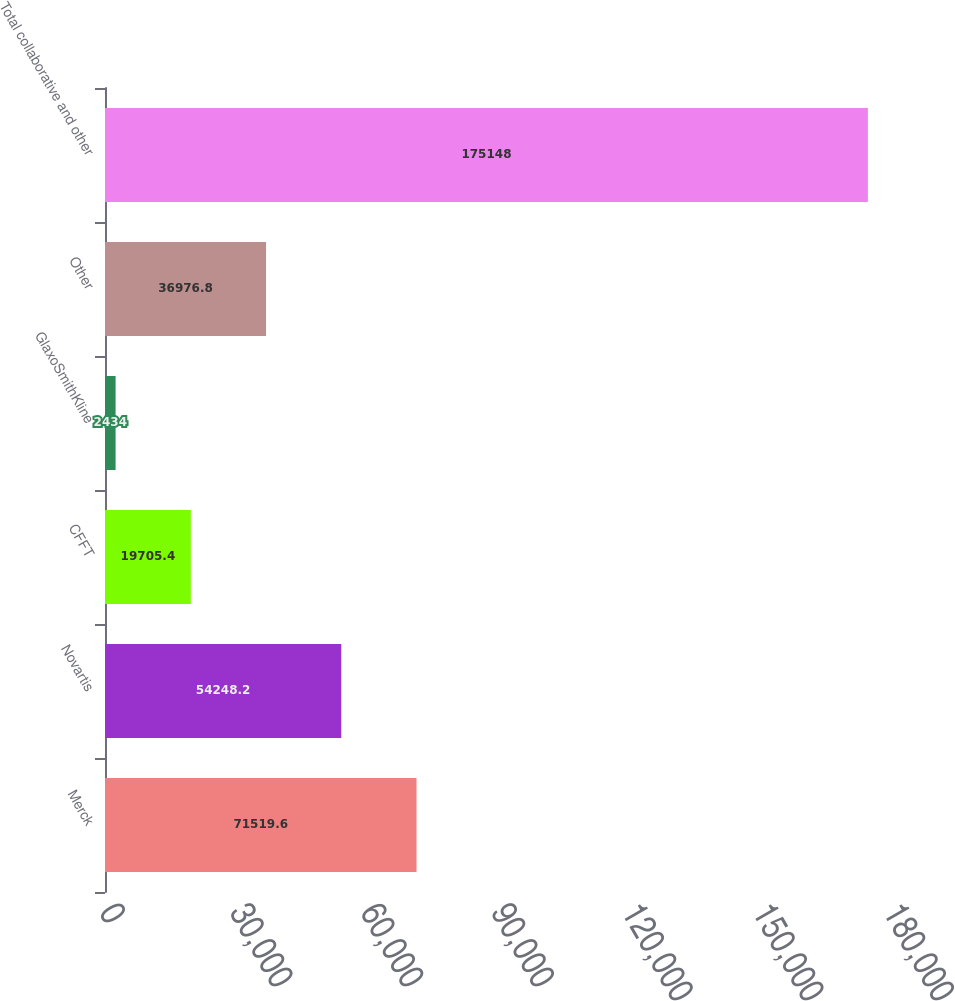<chart> <loc_0><loc_0><loc_500><loc_500><bar_chart><fcel>Merck<fcel>Novartis<fcel>CFFT<fcel>GlaxoSmithKline<fcel>Other<fcel>Total collaborative and other<nl><fcel>71519.6<fcel>54248.2<fcel>19705.4<fcel>2434<fcel>36976.8<fcel>175148<nl></chart> 